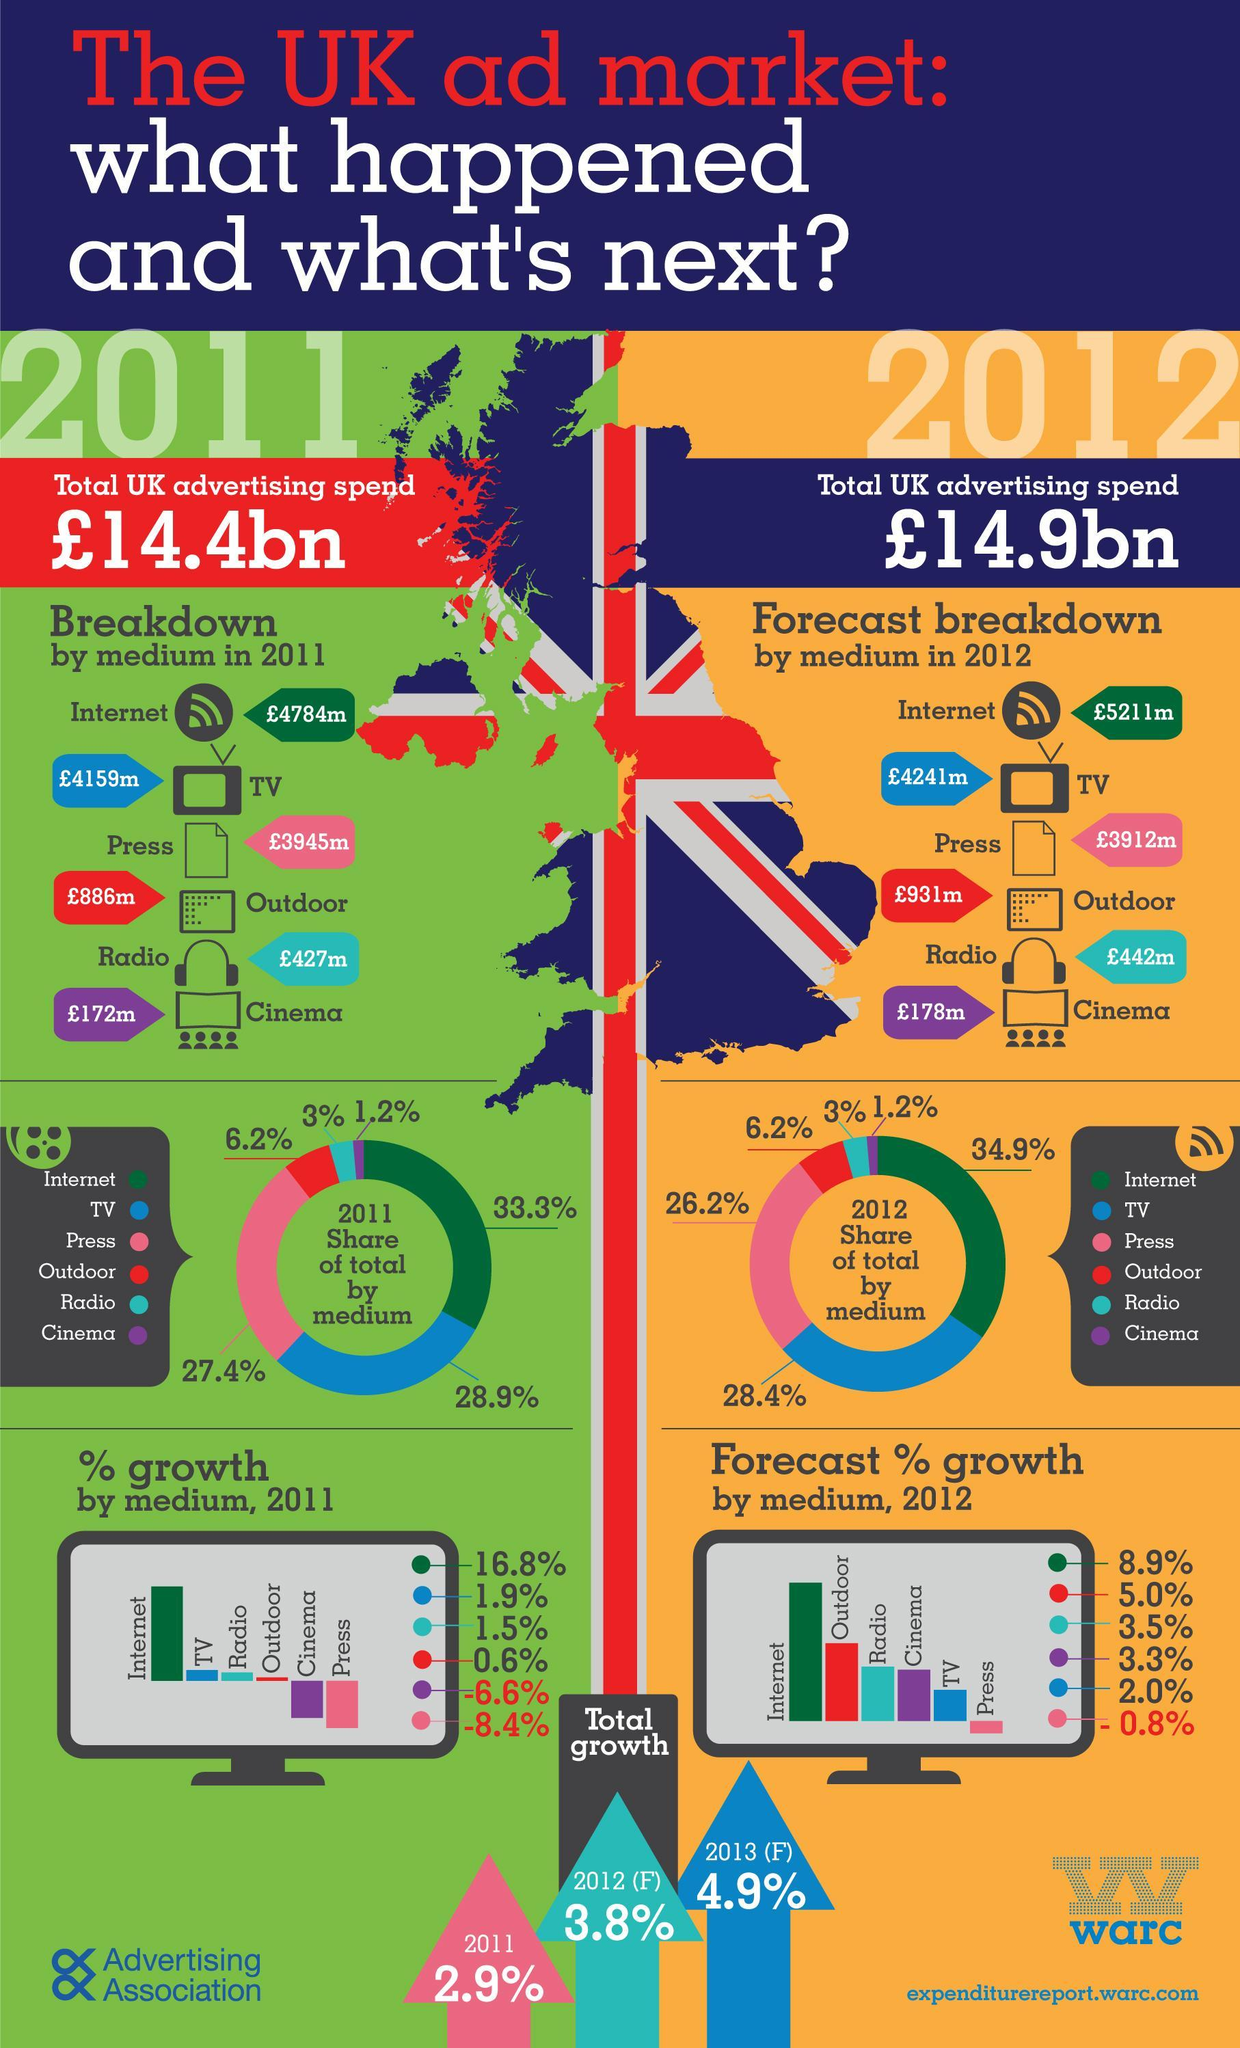In which year was a total advertising expenditure higher ?
Answer the question with a short phrase. 2012 On which advertising medium was most amount spent - press, outdoor, radio or internet ? Internet Which are the three mediums that have the same share % in both 2011 and 2012 ? Outdoor, radio, cinema How many mediums were used for advertising ? 5 In 2011, by what percent is the share of advertisement through TV greater than that of advertisement through press ? 1.5% What is the percentage share of Internet in advertising in 2011 ? 33.3 What is the percentage of total growth expected in 2013 ? 4.9% 